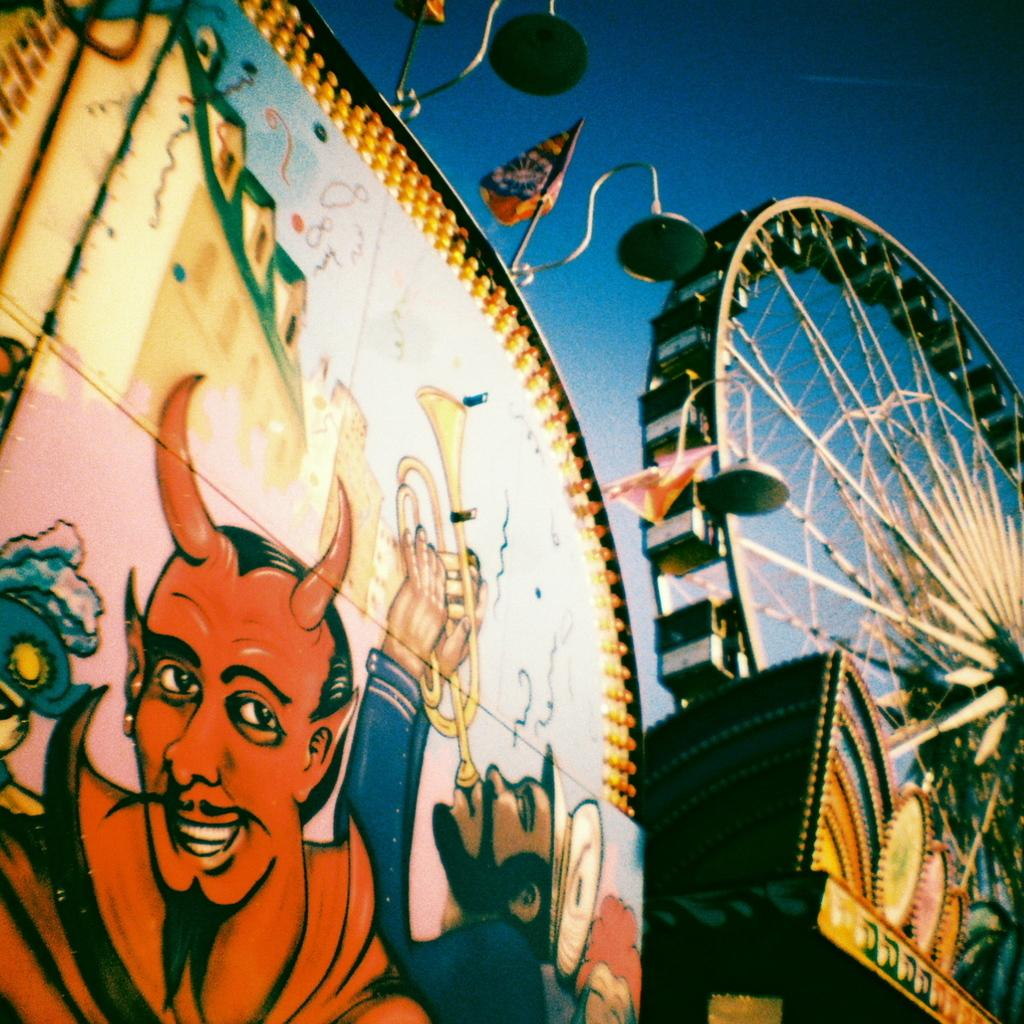What is the man on the left side of the image doing? The man on the left side of the image is blowing a trumpet. Who is beside the trumpet player? There is another man in the image, wearing red, who is beside the trumpet player. What is the color of the man's clothing? The man wearing red is beside the trumpet player. What can be seen on the right side of the side of the image? There is a joint wheel on the right side of the image. Is there any blood visible on the trumpet in the image? No, there is no blood visible on the trumpet in the image. Can you see a ring on the finger of the man wearing red? There is no mention of a ring or any jewelry in the image, so it cannot be determined if the man is wearing a ring. 